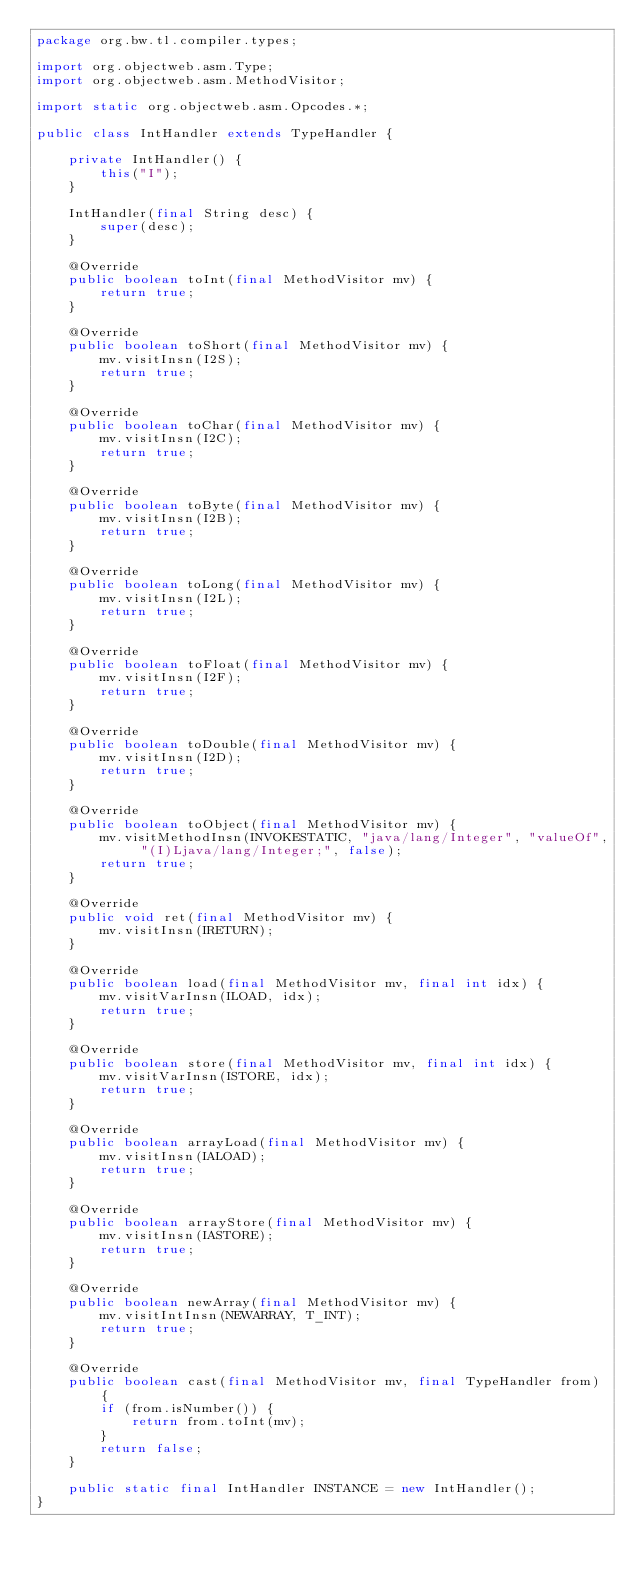<code> <loc_0><loc_0><loc_500><loc_500><_Java_>package org.bw.tl.compiler.types;

import org.objectweb.asm.Type;
import org.objectweb.asm.MethodVisitor;

import static org.objectweb.asm.Opcodes.*;

public class IntHandler extends TypeHandler {

    private IntHandler() {
        this("I");
    }

    IntHandler(final String desc) {
        super(desc);
    }

    @Override
    public boolean toInt(final MethodVisitor mv) {
        return true;
    }

    @Override
    public boolean toShort(final MethodVisitor mv) {
        mv.visitInsn(I2S);
        return true;
    }

    @Override
    public boolean toChar(final MethodVisitor mv) {
        mv.visitInsn(I2C);
        return true;
    }

    @Override
    public boolean toByte(final MethodVisitor mv) {
        mv.visitInsn(I2B);
        return true;
    }

    @Override
    public boolean toLong(final MethodVisitor mv) {
        mv.visitInsn(I2L);
        return true;
    }

    @Override
    public boolean toFloat(final MethodVisitor mv) {
        mv.visitInsn(I2F);
        return true;
    }

    @Override
    public boolean toDouble(final MethodVisitor mv) {
        mv.visitInsn(I2D);
        return true;
    }

    @Override
    public boolean toObject(final MethodVisitor mv) {
        mv.visitMethodInsn(INVOKESTATIC, "java/lang/Integer", "valueOf", "(I)Ljava/lang/Integer;", false);
        return true;
    }

    @Override
    public void ret(final MethodVisitor mv) {
        mv.visitInsn(IRETURN);
    }

    @Override
    public boolean load(final MethodVisitor mv, final int idx) {
        mv.visitVarInsn(ILOAD, idx);
        return true;
    }

    @Override
    public boolean store(final MethodVisitor mv, final int idx) {
        mv.visitVarInsn(ISTORE, idx);
        return true;
    }

    @Override
    public boolean arrayLoad(final MethodVisitor mv) {
        mv.visitInsn(IALOAD);
        return true;
    }

    @Override
    public boolean arrayStore(final MethodVisitor mv) {
        mv.visitInsn(IASTORE);
        return true;
    }

    @Override
    public boolean newArray(final MethodVisitor mv) {
        mv.visitIntInsn(NEWARRAY, T_INT);
        return true;
    }

    @Override
    public boolean cast(final MethodVisitor mv, final TypeHandler from) {
        if (from.isNumber()) {
            return from.toInt(mv);
        }
        return false;
    }

    public static final IntHandler INSTANCE = new IntHandler();
}
</code> 